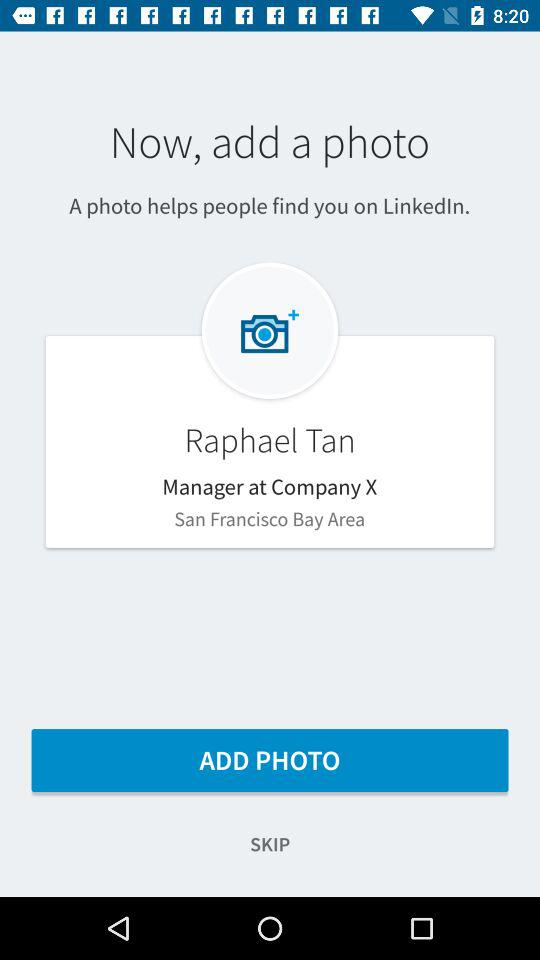What is the name of the application? The name of the application is "LinkedIn". 